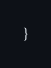<code> <loc_0><loc_0><loc_500><loc_500><_TypeScript_>}
</code> 